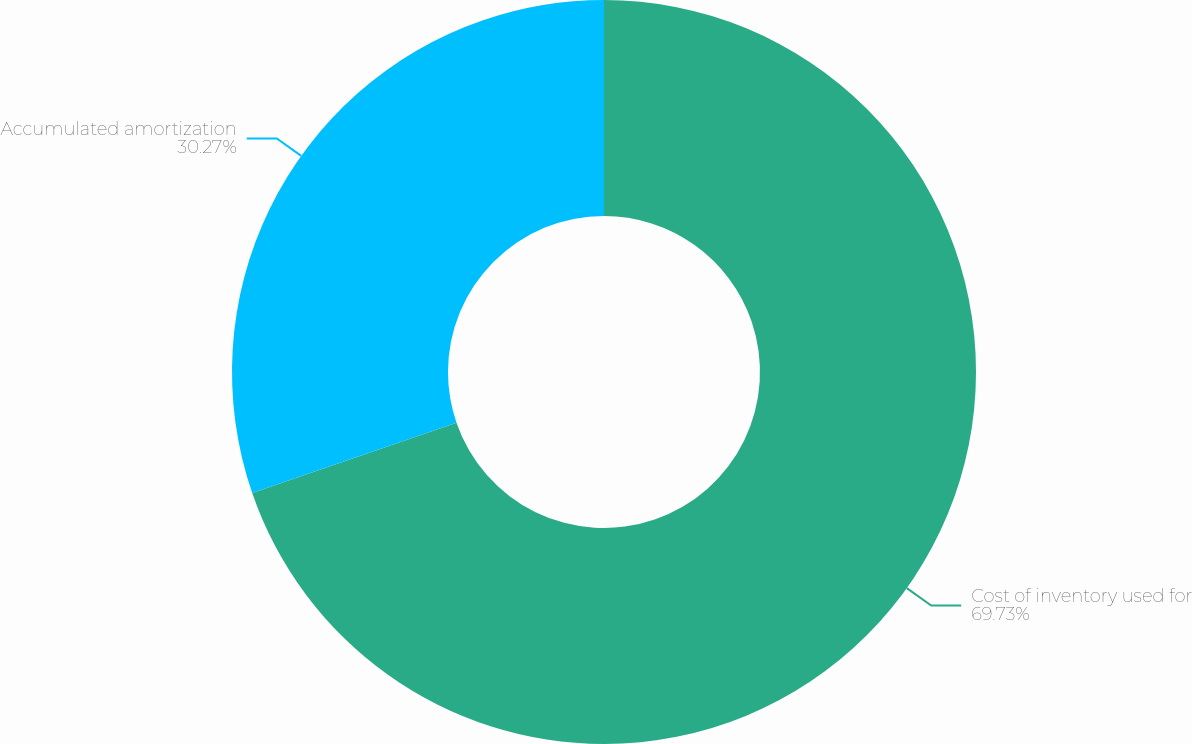Convert chart. <chart><loc_0><loc_0><loc_500><loc_500><pie_chart><fcel>Cost of inventory used for<fcel>Accumulated amortization<nl><fcel>69.73%<fcel>30.27%<nl></chart> 